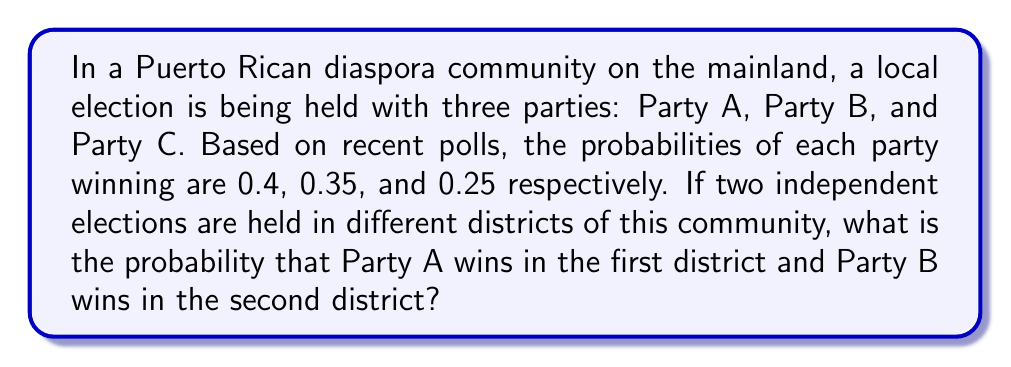What is the answer to this math problem? To solve this problem, we need to follow these steps:

1. Identify the probabilities for each party:
   Party A: $P(A) = 0.4$
   Party B: $P(B) = 0.35$
   Party C: $P(C) = 0.25$

2. Recognize that we need to calculate the probability of two independent events occurring:
   - Party A winning in the first district
   - Party B winning in the second district

3. For independent events, we multiply their individual probabilities:

   $$P(\text{A wins 1st and B wins 2nd}) = P(\text{A wins 1st}) \times P(\text{B wins 2nd})$$

4. Substitute the given probabilities:

   $$P(\text{A wins 1st and B wins 2nd}) = 0.4 \times 0.35$$

5. Calculate the final probability:

   $$P(\text{A wins 1st and B wins 2nd}) = 0.14$$

Therefore, the probability that Party A wins in the first district and Party B wins in the second district is 0.14 or 14%.
Answer: 0.14 